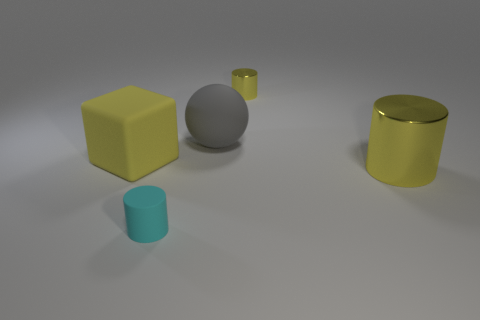Subtract all metal cylinders. How many cylinders are left? 1 Subtract 1 cylinders. How many cylinders are left? 2 Add 2 cyan cylinders. How many objects exist? 7 Subtract 0 green spheres. How many objects are left? 5 Subtract all cylinders. How many objects are left? 2 Subtract all gray rubber spheres. Subtract all big cylinders. How many objects are left? 3 Add 2 gray matte objects. How many gray matte objects are left? 3 Add 4 rubber cylinders. How many rubber cylinders exist? 5 